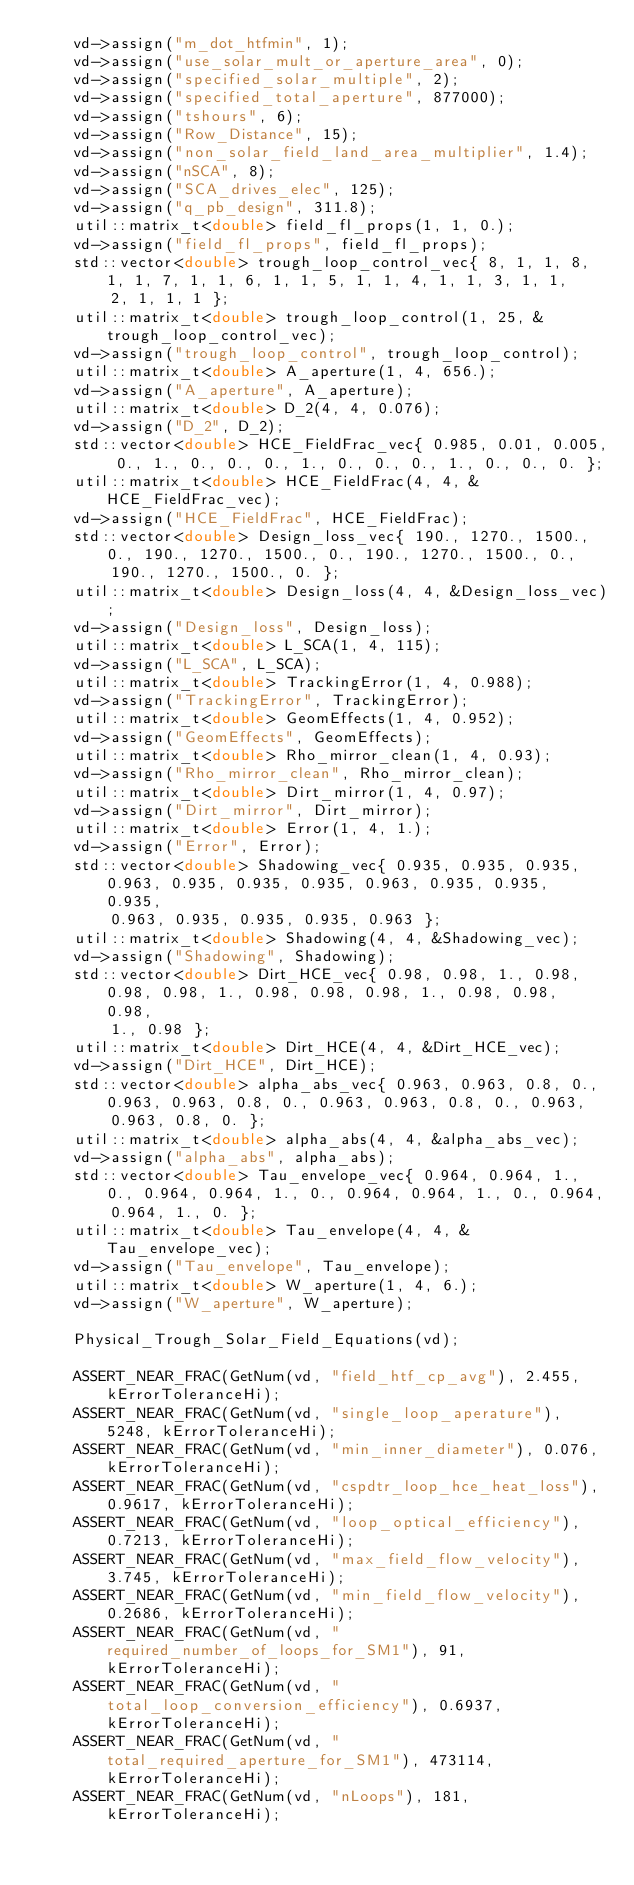<code> <loc_0><loc_0><loc_500><loc_500><_C++_>    vd->assign("m_dot_htfmin", 1);
    vd->assign("use_solar_mult_or_aperture_area", 0);
    vd->assign("specified_solar_multiple", 2);
    vd->assign("specified_total_aperture", 877000);
    vd->assign("tshours", 6);
    vd->assign("Row_Distance", 15);
    vd->assign("non_solar_field_land_area_multiplier", 1.4);
    vd->assign("nSCA", 8);
    vd->assign("SCA_drives_elec", 125);
    vd->assign("q_pb_design", 311.8);
    util::matrix_t<double> field_fl_props(1, 1, 0.);
    vd->assign("field_fl_props", field_fl_props);
    std::vector<double> trough_loop_control_vec{ 8, 1, 1, 8, 1, 1, 7, 1, 1, 6, 1, 1, 5, 1, 1, 4, 1, 1, 3, 1, 1,
        2, 1, 1, 1 };
    util::matrix_t<double> trough_loop_control(1, 25, &trough_loop_control_vec);
    vd->assign("trough_loop_control", trough_loop_control);
    util::matrix_t<double> A_aperture(1, 4, 656.);
    vd->assign("A_aperture", A_aperture);
    util::matrix_t<double> D_2(4, 4, 0.076);
    vd->assign("D_2", D_2);
    std::vector<double> HCE_FieldFrac_vec{ 0.985, 0.01, 0.005, 0., 1., 0., 0., 0., 1., 0., 0., 0., 1., 0., 0., 0. };
    util::matrix_t<double> HCE_FieldFrac(4, 4, &HCE_FieldFrac_vec);
    vd->assign("HCE_FieldFrac", HCE_FieldFrac);
    std::vector<double> Design_loss_vec{ 190., 1270., 1500., 0., 190., 1270., 1500., 0., 190., 1270., 1500., 0.,
        190., 1270., 1500., 0. };
    util::matrix_t<double> Design_loss(4, 4, &Design_loss_vec);
    vd->assign("Design_loss", Design_loss);
    util::matrix_t<double> L_SCA(1, 4, 115);
    vd->assign("L_SCA", L_SCA);
    util::matrix_t<double> TrackingError(1, 4, 0.988);
    vd->assign("TrackingError", TrackingError);
    util::matrix_t<double> GeomEffects(1, 4, 0.952);
    vd->assign("GeomEffects", GeomEffects);
    util::matrix_t<double> Rho_mirror_clean(1, 4, 0.93);
    vd->assign("Rho_mirror_clean", Rho_mirror_clean);
    util::matrix_t<double> Dirt_mirror(1, 4, 0.97);
    vd->assign("Dirt_mirror", Dirt_mirror);
    util::matrix_t<double> Error(1, 4, 1.);
    vd->assign("Error", Error);
    std::vector<double> Shadowing_vec{ 0.935, 0.935, 0.935, 0.963, 0.935, 0.935, 0.935, 0.963, 0.935, 0.935, 0.935,
        0.963, 0.935, 0.935, 0.935, 0.963 };
    util::matrix_t<double> Shadowing(4, 4, &Shadowing_vec);
    vd->assign("Shadowing", Shadowing);
    std::vector<double> Dirt_HCE_vec{ 0.98, 0.98, 1., 0.98, 0.98, 0.98, 1., 0.98, 0.98, 0.98, 1., 0.98, 0.98, 0.98,
        1., 0.98 };
    util::matrix_t<double> Dirt_HCE(4, 4, &Dirt_HCE_vec);
    vd->assign("Dirt_HCE", Dirt_HCE);
    std::vector<double> alpha_abs_vec{ 0.963, 0.963, 0.8, 0., 0.963, 0.963, 0.8, 0., 0.963, 0.963, 0.8, 0., 0.963,
        0.963, 0.8, 0. };
    util::matrix_t<double> alpha_abs(4, 4, &alpha_abs_vec);
    vd->assign("alpha_abs", alpha_abs);
    std::vector<double> Tau_envelope_vec{ 0.964, 0.964, 1., 0., 0.964, 0.964, 1., 0., 0.964, 0.964, 1., 0., 0.964,
        0.964, 1., 0. };
    util::matrix_t<double> Tau_envelope(4, 4, &Tau_envelope_vec);
    vd->assign("Tau_envelope", Tau_envelope);
    util::matrix_t<double> W_aperture(1, 4, 6.);
    vd->assign("W_aperture", W_aperture);

    Physical_Trough_Solar_Field_Equations(vd);

    ASSERT_NEAR_FRAC(GetNum(vd, "field_htf_cp_avg"), 2.455, kErrorToleranceHi);
    ASSERT_NEAR_FRAC(GetNum(vd, "single_loop_aperature"), 5248, kErrorToleranceHi);
    ASSERT_NEAR_FRAC(GetNum(vd, "min_inner_diameter"), 0.076, kErrorToleranceHi);
    ASSERT_NEAR_FRAC(GetNum(vd, "cspdtr_loop_hce_heat_loss"), 0.9617, kErrorToleranceHi);
    ASSERT_NEAR_FRAC(GetNum(vd, "loop_optical_efficiency"), 0.7213, kErrorToleranceHi);
    ASSERT_NEAR_FRAC(GetNum(vd, "max_field_flow_velocity"), 3.745, kErrorToleranceHi);
    ASSERT_NEAR_FRAC(GetNum(vd, "min_field_flow_velocity"), 0.2686, kErrorToleranceHi);
    ASSERT_NEAR_FRAC(GetNum(vd, "required_number_of_loops_for_SM1"), 91, kErrorToleranceHi);
    ASSERT_NEAR_FRAC(GetNum(vd, "total_loop_conversion_efficiency"), 0.6937, kErrorToleranceHi);
    ASSERT_NEAR_FRAC(GetNum(vd, "total_required_aperture_for_SM1"), 473114, kErrorToleranceHi);
    ASSERT_NEAR_FRAC(GetNum(vd, "nLoops"), 181, kErrorToleranceHi);</code> 